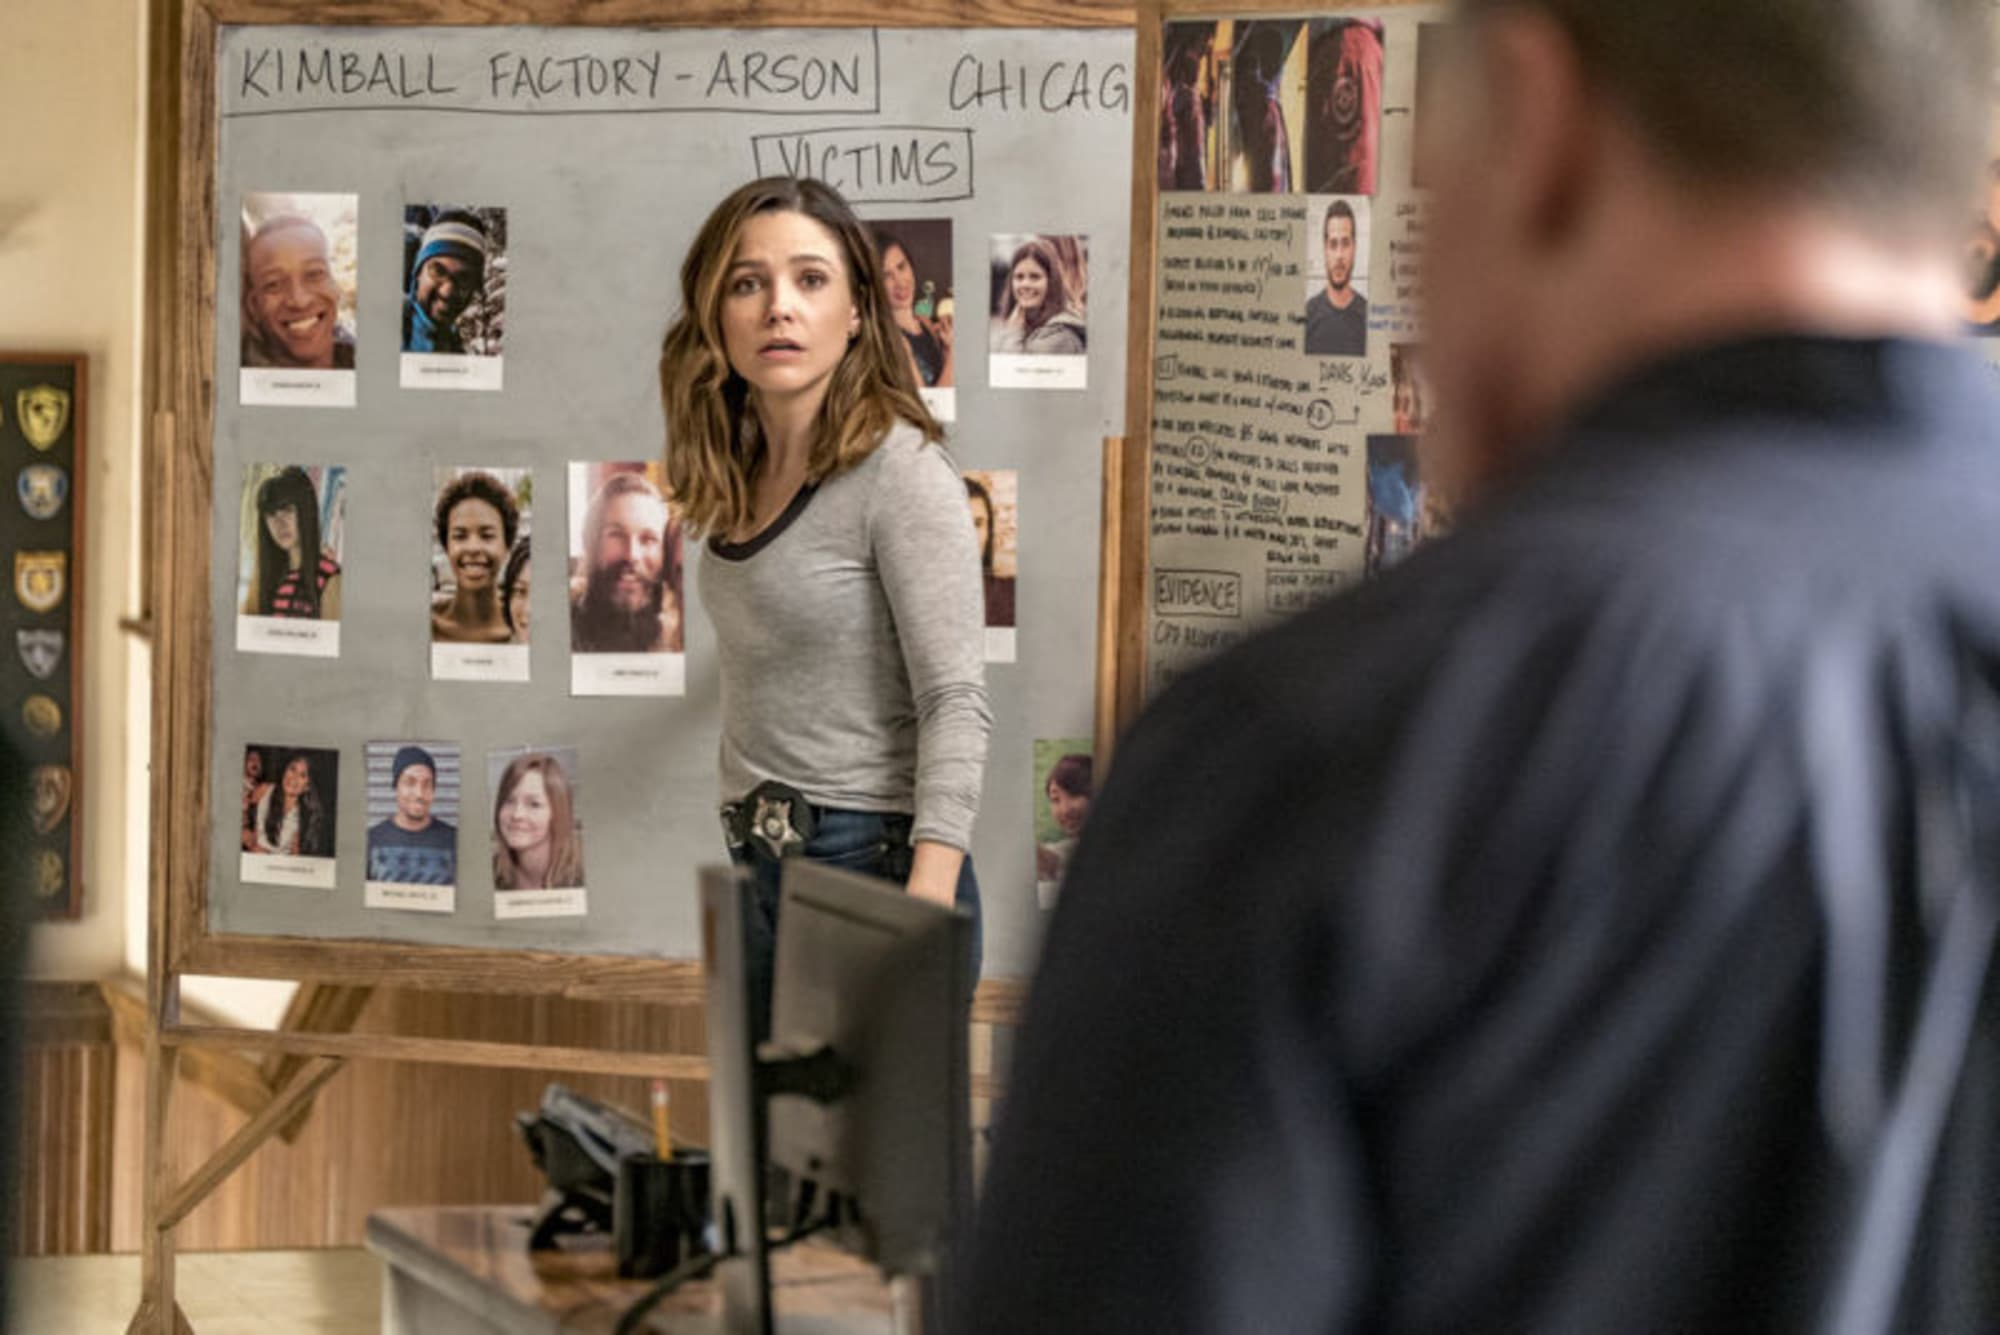Explain the significance of the items on the bulletin board. The bulletin board in the image serves a crucial role in the investigation depicted. It's laden with photos and information about victims of the arson at Kimball Factory, making it a key tool for organizing the inquiry. Each photo is paired with details that likely help the investigators track connections, timelines, and other relevant data. The presence of such a board typically helps in creating a visual aid that aids in understanding relationships and patterns that might not be as obvious through other forms of data aggregation. How does the design of the room contribute to the feeling of the image? The room's design, with its wooden furniture, muted tones, and the clutter of work materials, contributes to a realistic and gritty setting that matches the seriousness of the case being investigated. It feels lived-in and practical, which underlines the ongoing nature of police work. The atmosphere is utilitarian, meant for focus and efficiency, which aligns well with the somber task of solving a major crime. 